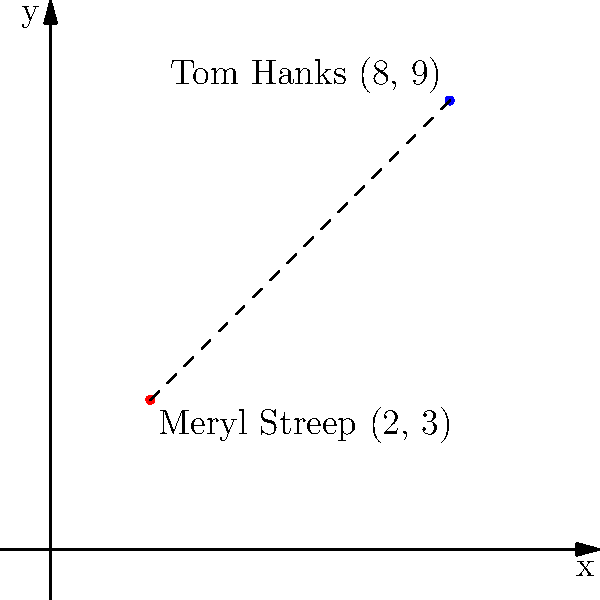In a Cartesian coordinate system representing the birthplaces of Oscar-winning actors, Meryl Streep's birthplace is located at (2, 3), while Tom Hanks' birthplace is at (8, 9). Calculate the distance between their birthplaces using the distance formula. To find the distance between two points in a Cartesian coordinate system, we use the distance formula:

$$d = \sqrt{(x_2 - x_1)^2 + (y_2 - y_1)^2}$$

Where $(x_1, y_1)$ represents the coordinates of the first point and $(x_2, y_2)$ represents the coordinates of the second point.

Step 1: Identify the coordinates
Meryl Streep: $(x_1, y_1) = (2, 3)$
Tom Hanks: $(x_2, y_2) = (8, 9)$

Step 2: Substitute the values into the distance formula
$$d = \sqrt{(8 - 2)^2 + (9 - 3)^2}$$

Step 3: Simplify the expressions inside the parentheses
$$d = \sqrt{6^2 + 6^2}$$

Step 4: Calculate the squares
$$d = \sqrt{36 + 36}$$

Step 5: Add the values under the square root
$$d = \sqrt{72}$$

Step 6: Simplify the square root
$$d = 6\sqrt{2}$$

Therefore, the distance between Meryl Streep's and Tom Hanks' birthplaces is $6\sqrt{2}$ units.
Answer: $6\sqrt{2}$ units 